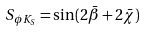<formula> <loc_0><loc_0><loc_500><loc_500>S _ { \phi K _ { S } } = \sin ( 2 \bar { \beta } + 2 \bar { \chi } )</formula> 